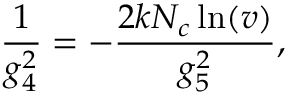<formula> <loc_0><loc_0><loc_500><loc_500>\frac { 1 } { g _ { 4 } ^ { 2 } } = - \frac { 2 k N _ { c } \ln ( v ) } { g _ { 5 } ^ { 2 } } ,</formula> 